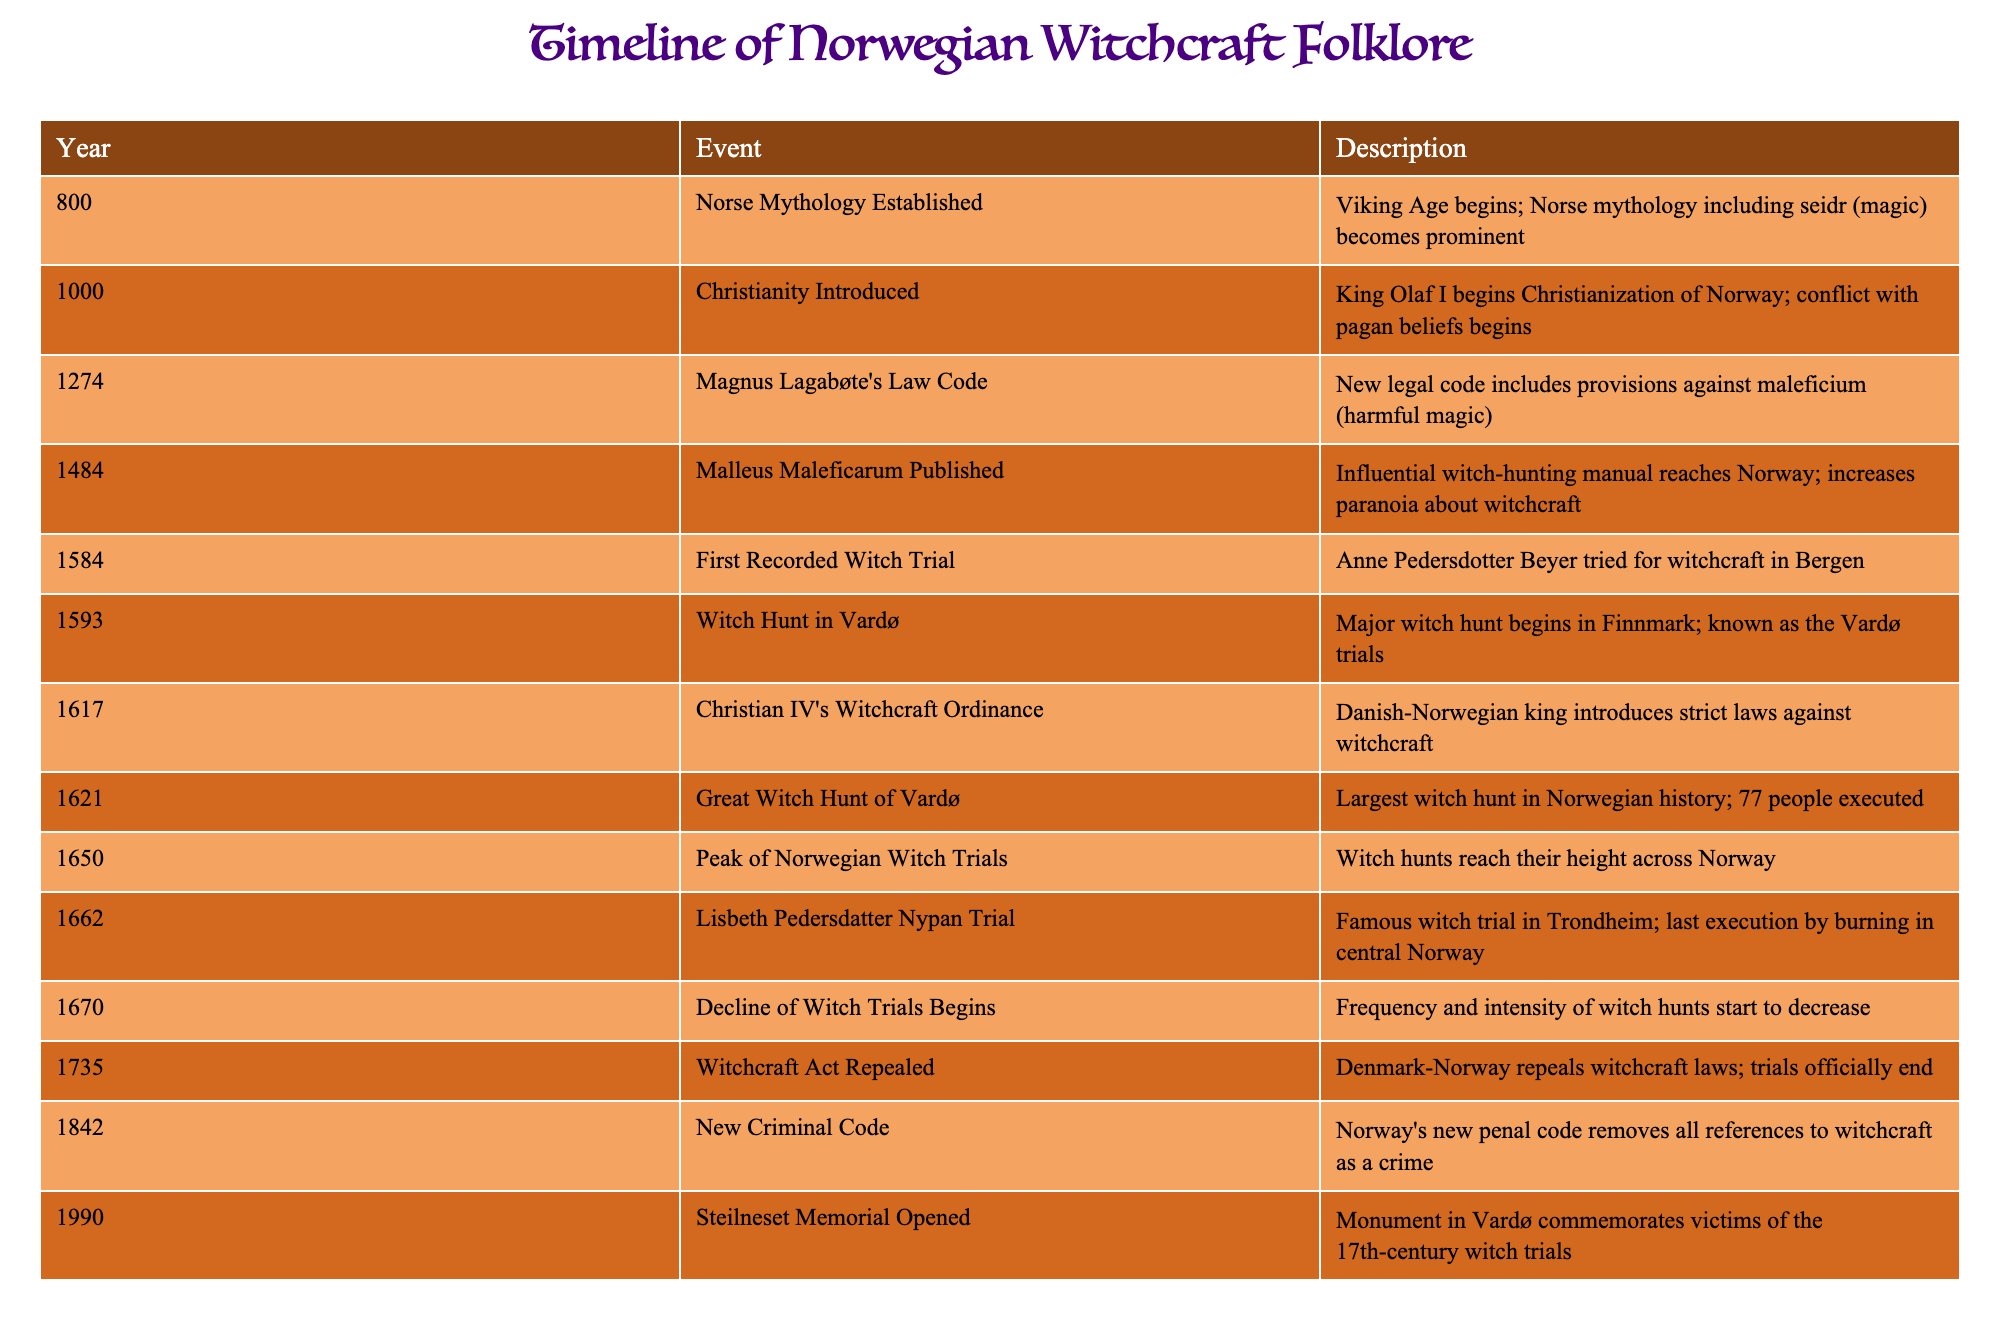What year did the first recorded witch trial occur in Norway? The table lists events related to witchcraft in Norway, specifically highlighting "First Recorded Witch Trial" which occurred in the year 1584.
Answer: 1584 What was the legal impact of Magnus Lagabøte's Law Code in 1274? According to the table, Magnus Lagabøte's Law Code introduced provisions against maleficium, which refers to harmful magic, marking an early legal acknowledgment of witchcraft in Norway.
Answer: Provisions against harmful magic were introduced How many people were executed during the Great Witch Hunt of Vardø in 1621? The event titled "Great Witch Hunt of Vardø" in the table specifies that 77 people were executed during this particular witch hunt in 1621.
Answer: 77 people Which two events signify the beginning and end of witch trials in Norway? The table indicates that the witch trials began with "First Recorded Witch Trial" in 1584 and ended with the repeal of the "Witchcraft Act" in 1735, summing up the timeline of witch trials in Norway.
Answer: 1584 and 1735 Was there a notable decline in witch trials by 1670? Referring to the table, it shows that in 1670, the "Decline of Witch Trials Begins," which suggests that the witch trials were indeed decreasing in frequency and intensity at that time.
Answer: Yes How many years passed between the repeal of witchcraft laws in 1735 and the opening of the Steilneset Memorial in 1990? To find the duration, subtract 1735 from 1990: 1990 - 1735 = 255 years. This calculation identifies the length of time between the legal end of witchcraft trials and the memorial opening.
Answer: 255 years What major cultural shift began in 1000 that might have contributed to the witch trials? The table notes "Christianity Introduced" in 1000, which led to the conflict with pagan beliefs, potentially increasing scrutiny and trials against those accused of witchcraft as pagan practices were denounced.
Answer: Conflict with pagan beliefs increased During which event did the frequency of witch hunts reach its peak in Norway? The table indicates that "Peak of Norwegian Witch Trials" occurred in 1650, suggesting this year marked the highest intensity of witch hunts in Norway's history.
Answer: 1650 What significant social change occurred in the year 1842 regarding witchcraft? The table states that a "New Criminal Code" was introduced in 1842, which removed all references to witchcraft as a crime, signifying a major social change in the legal perspective of witchcraft in Norway.
Answer: Witchcraft was no longer considered a crime 